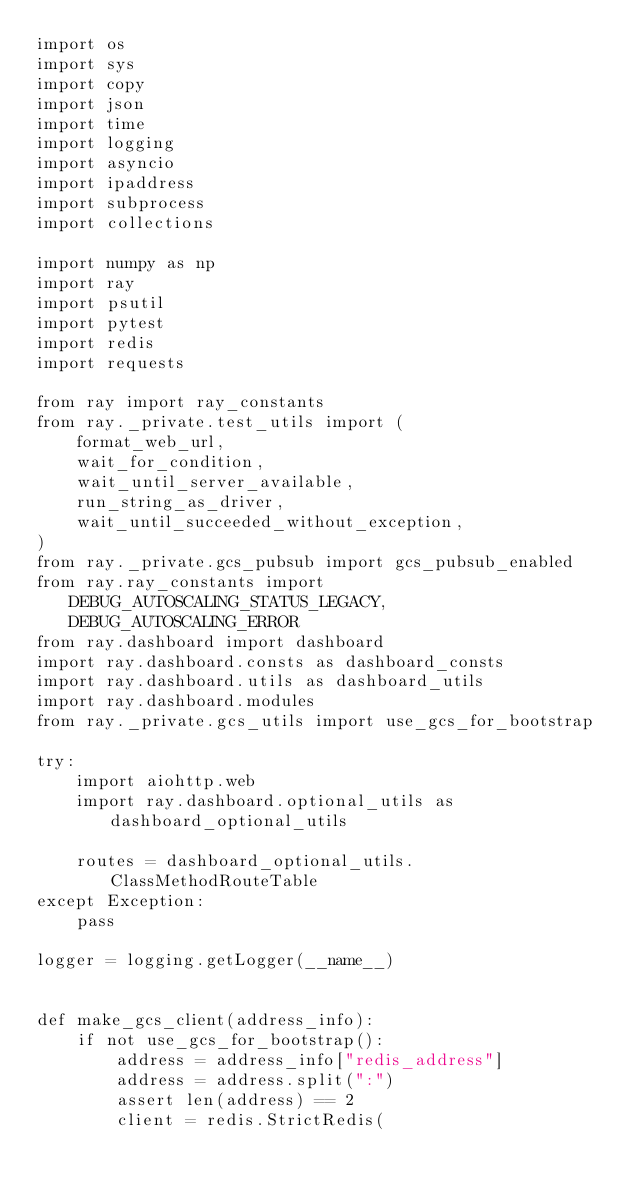Convert code to text. <code><loc_0><loc_0><loc_500><loc_500><_Python_>import os
import sys
import copy
import json
import time
import logging
import asyncio
import ipaddress
import subprocess
import collections

import numpy as np
import ray
import psutil
import pytest
import redis
import requests

from ray import ray_constants
from ray._private.test_utils import (
    format_web_url,
    wait_for_condition,
    wait_until_server_available,
    run_string_as_driver,
    wait_until_succeeded_without_exception,
)
from ray._private.gcs_pubsub import gcs_pubsub_enabled
from ray.ray_constants import DEBUG_AUTOSCALING_STATUS_LEGACY, DEBUG_AUTOSCALING_ERROR
from ray.dashboard import dashboard
import ray.dashboard.consts as dashboard_consts
import ray.dashboard.utils as dashboard_utils
import ray.dashboard.modules
from ray._private.gcs_utils import use_gcs_for_bootstrap

try:
    import aiohttp.web
    import ray.dashboard.optional_utils as dashboard_optional_utils

    routes = dashboard_optional_utils.ClassMethodRouteTable
except Exception:
    pass

logger = logging.getLogger(__name__)


def make_gcs_client(address_info):
    if not use_gcs_for_bootstrap():
        address = address_info["redis_address"]
        address = address.split(":")
        assert len(address) == 2
        client = redis.StrictRedis(</code> 